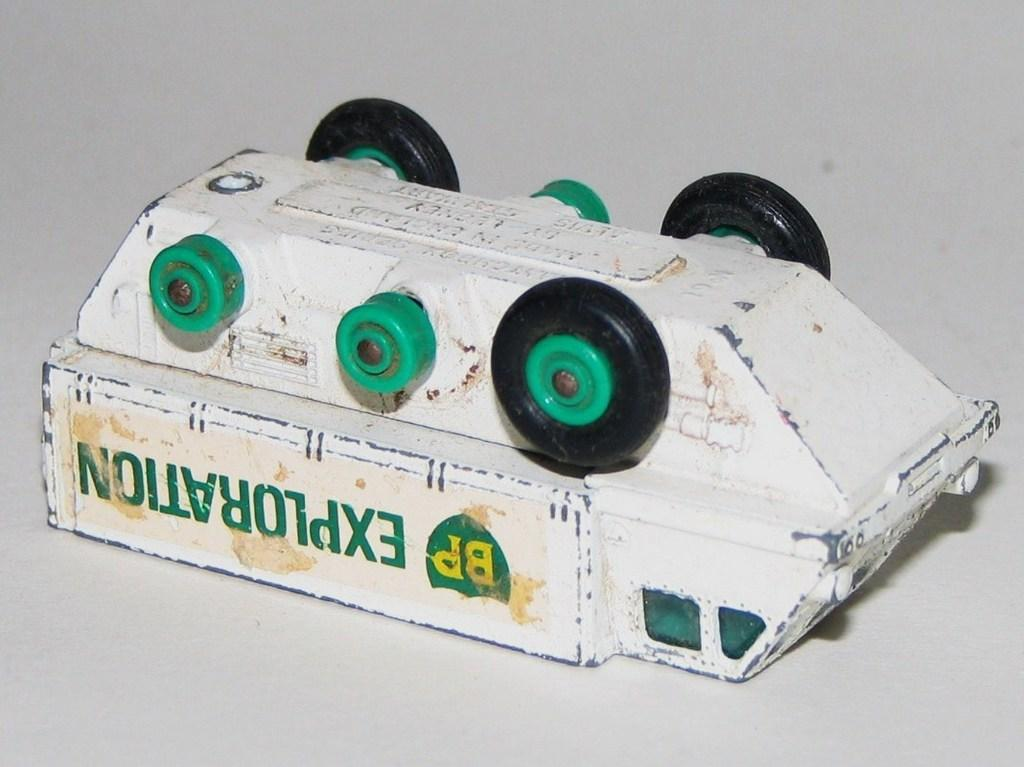What object can be seen in the image that might be considered a toy? There is a toy in the image. What type of cream is being served in the lunchroom in the image? There is no lunchroom or cream present in the image; it only features a toy. 